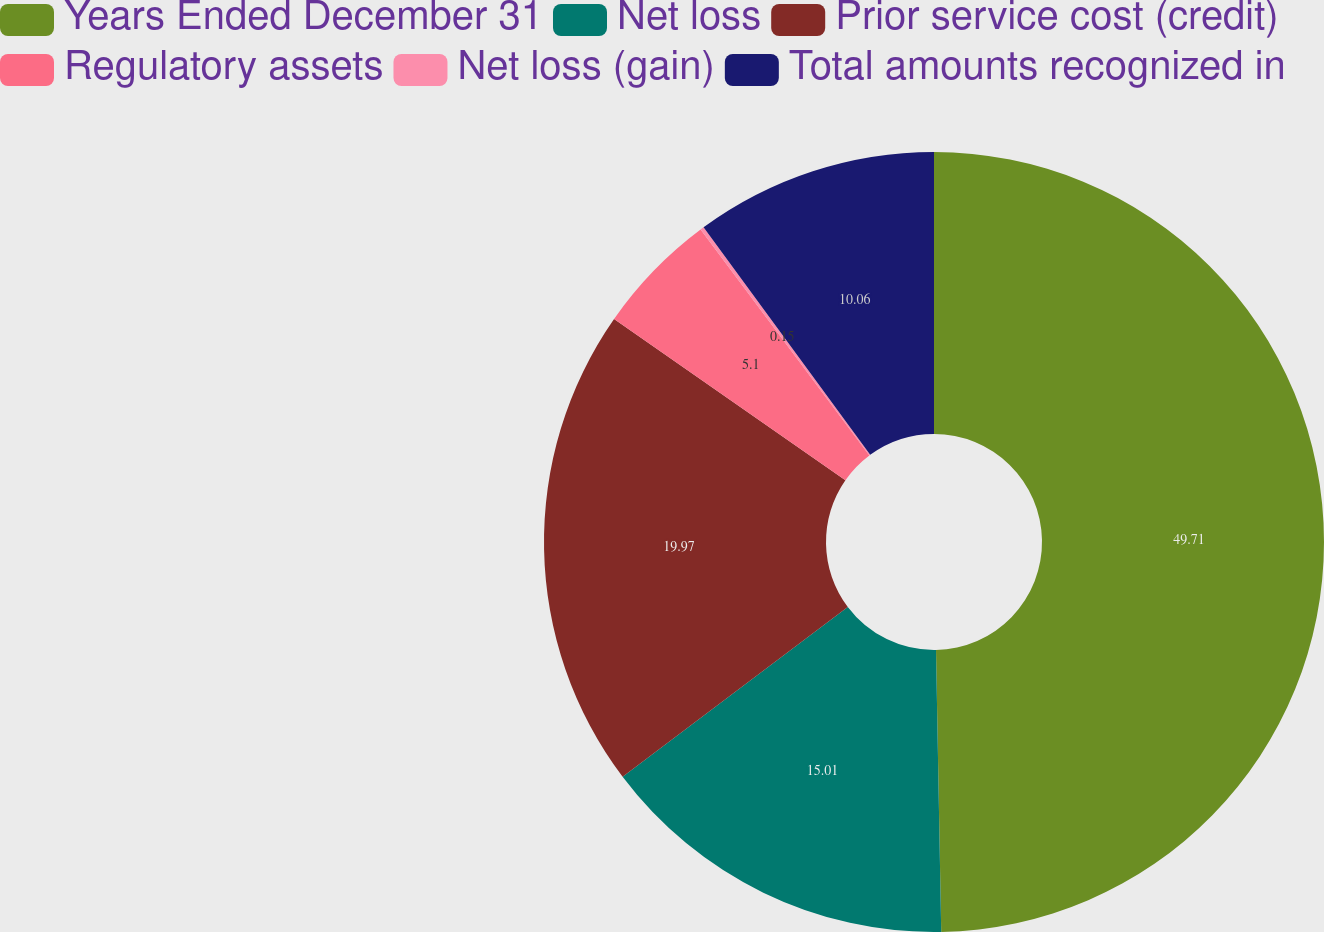Convert chart. <chart><loc_0><loc_0><loc_500><loc_500><pie_chart><fcel>Years Ended December 31<fcel>Net loss<fcel>Prior service cost (credit)<fcel>Regulatory assets<fcel>Net loss (gain)<fcel>Total amounts recognized in<nl><fcel>49.7%<fcel>15.01%<fcel>19.97%<fcel>5.1%<fcel>0.15%<fcel>10.06%<nl></chart> 